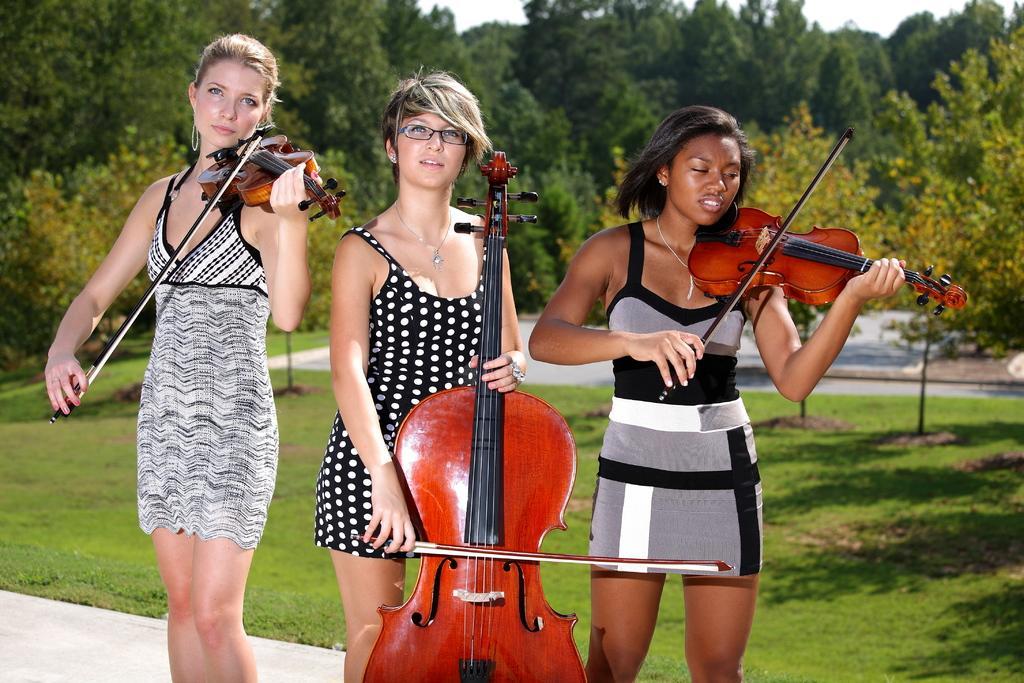Describe this image in one or two sentences. On the background we can see trees. A fresh green grass and plants. Here we can see three women standing and playing violin. 